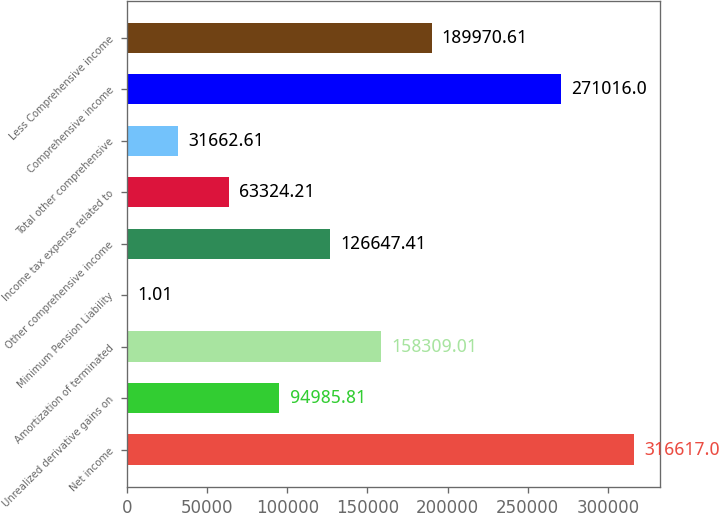Convert chart. <chart><loc_0><loc_0><loc_500><loc_500><bar_chart><fcel>Net income<fcel>Unrealized derivative gains on<fcel>Amortization of terminated<fcel>Minimum Pension Liability<fcel>Other comprehensive income<fcel>Income tax expense related to<fcel>Total other comprehensive<fcel>Comprehensive income<fcel>Less Comprehensive income<nl><fcel>316617<fcel>94985.8<fcel>158309<fcel>1.01<fcel>126647<fcel>63324.2<fcel>31662.6<fcel>271016<fcel>189971<nl></chart> 